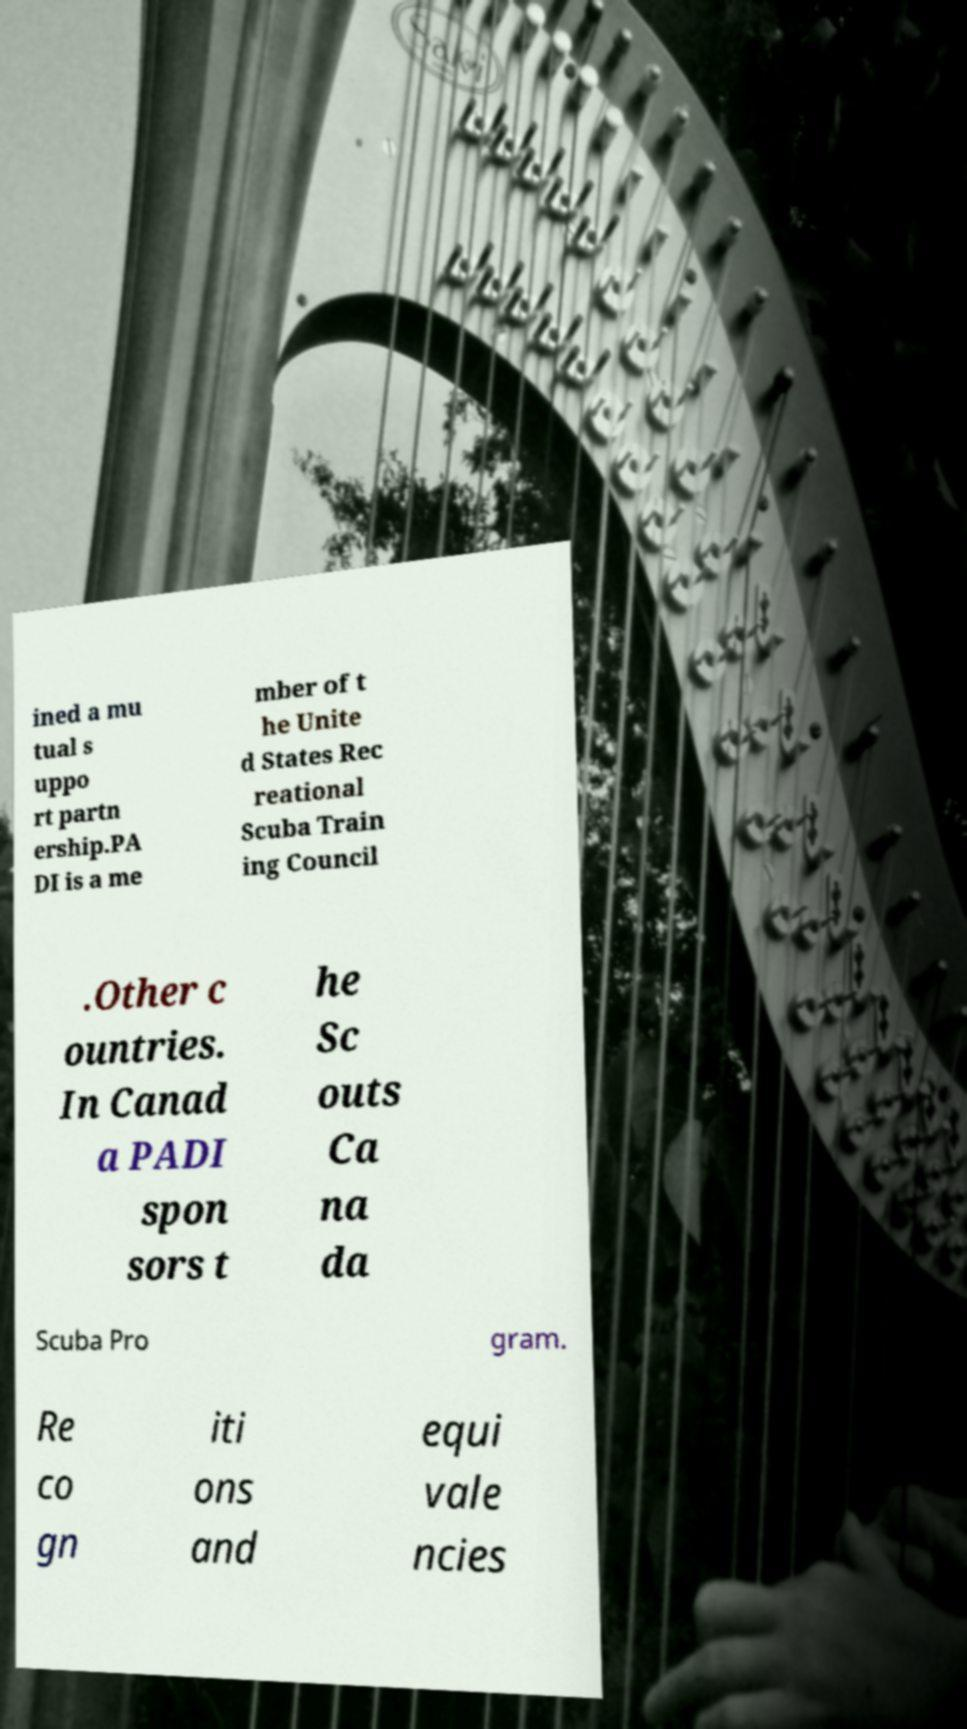Could you extract and type out the text from this image? ined a mu tual s uppo rt partn ership.PA DI is a me mber of t he Unite d States Rec reational Scuba Train ing Council .Other c ountries. In Canad a PADI spon sors t he Sc outs Ca na da Scuba Pro gram. Re co gn iti ons and equi vale ncies 